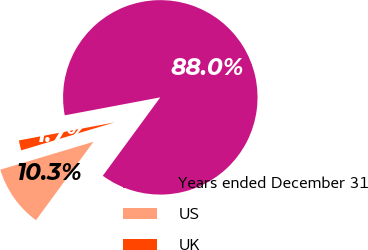<chart> <loc_0><loc_0><loc_500><loc_500><pie_chart><fcel>Years ended December 31<fcel>US<fcel>UK<nl><fcel>88.03%<fcel>10.3%<fcel>1.67%<nl></chart> 